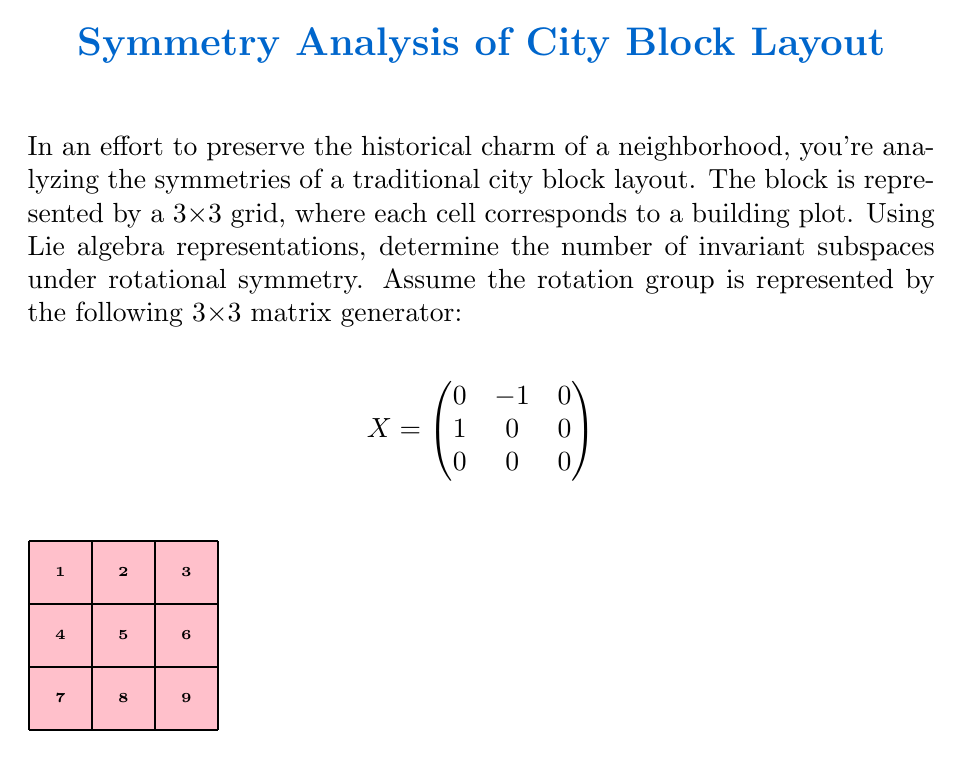Solve this math problem. To solve this problem, we'll follow these steps:

1) First, we need to understand what the given matrix $X$ represents. It's the infinitesimal generator of rotations in the xy-plane, leaving the z-coordinate unchanged.

2) The invariant subspaces are those subspaces of the 9-dimensional vector space (representing the 3x3 grid) that remain unchanged under the action of this rotation.

3) Let's consider how the rotation affects different parts of the grid:

   a) The center cell (5) is invariant under rotation.
   b) The corner cells (1, 3, 7, 9) form an invariant subspace.
   c) The edge cells (2, 4, 6, 8) form another invariant subspace.

4) Now, let's look at these subspaces in terms of vectors:

   a) $v_1 = (0,0,0,0,1,0,0,0,0)$ represents the center cell.
   b) $v_2 = (1,0,1,0,0,0,1,0,1)$ represents the corner cells.
   c) $v_3 = (0,1,0,1,0,1,0,1,0)$ represents the edge cells.

5) These vectors form a basis for the invariant subspaces. We can verify that each of these vectors is indeed invariant under the action of $X$.

6) Additionally, any linear combination of these vectors will also be invariant. Therefore, the space spanned by these vectors forms the complete set of invariant subspaces.

7) The number of invariant subspaces is thus equal to the dimension of the space spanned by these vectors, which is 3.

This analysis shows how Lie algebra representations can be used to identify symmetries in urban layouts, helping to preserve the historical charm of the neighborhood while understanding its underlying structure.
Answer: 3 invariant subspaces 